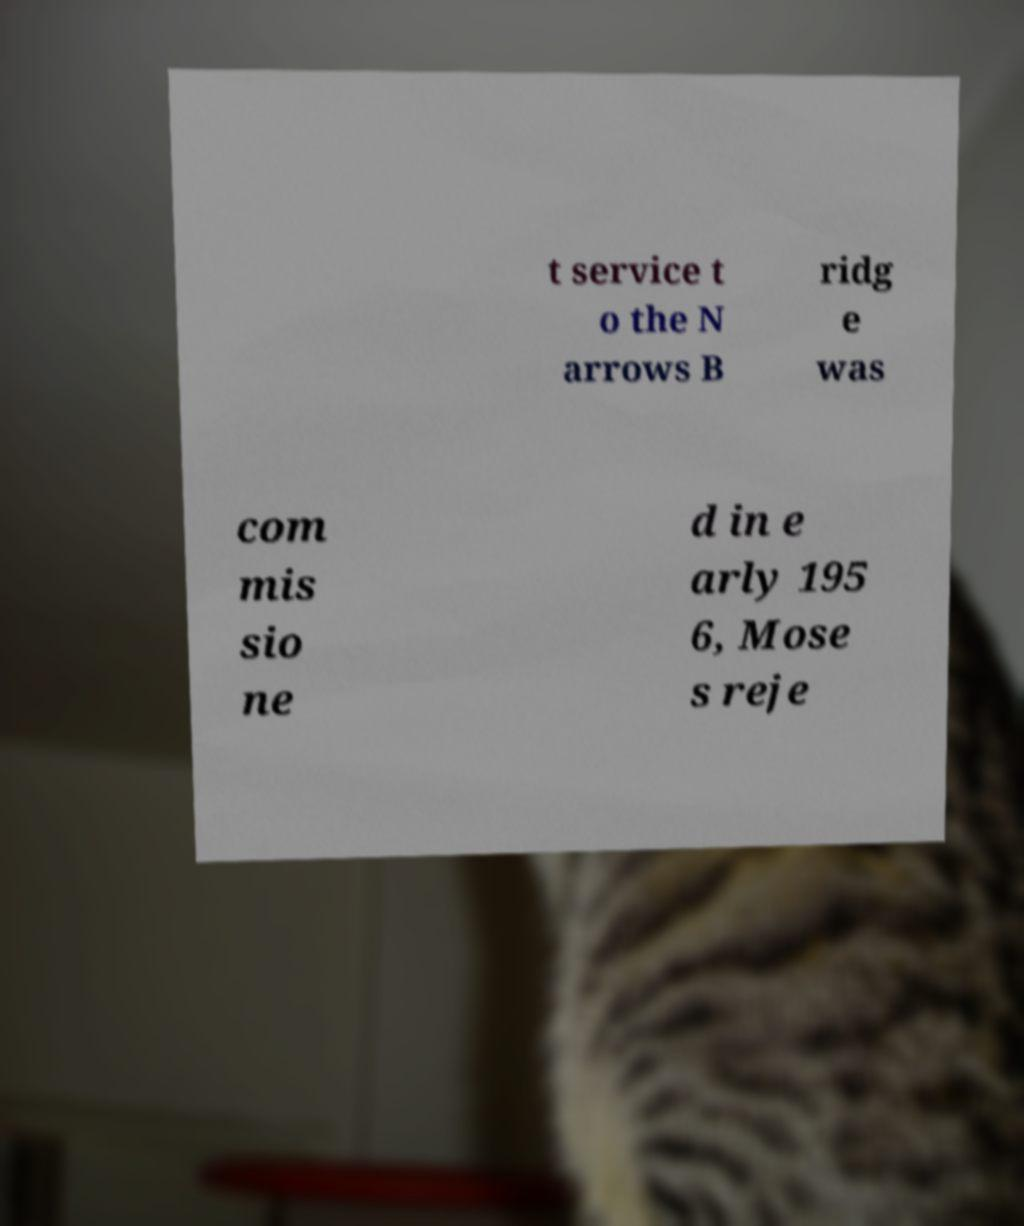I need the written content from this picture converted into text. Can you do that? t service t o the N arrows B ridg e was com mis sio ne d in e arly 195 6, Mose s reje 